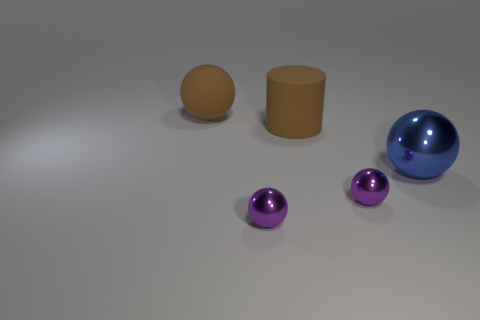Subtract 1 balls. How many balls are left? 3 Subtract all shiny balls. How many balls are left? 1 Add 4 large brown rubber cylinders. How many objects exist? 9 Subtract all red spheres. Subtract all blue blocks. How many spheres are left? 4 Subtract all spheres. How many objects are left? 1 Add 3 small metal spheres. How many small metal spheres are left? 5 Add 1 metallic balls. How many metallic balls exist? 4 Subtract 0 gray balls. How many objects are left? 5 Subtract all large brown matte cylinders. Subtract all matte balls. How many objects are left? 3 